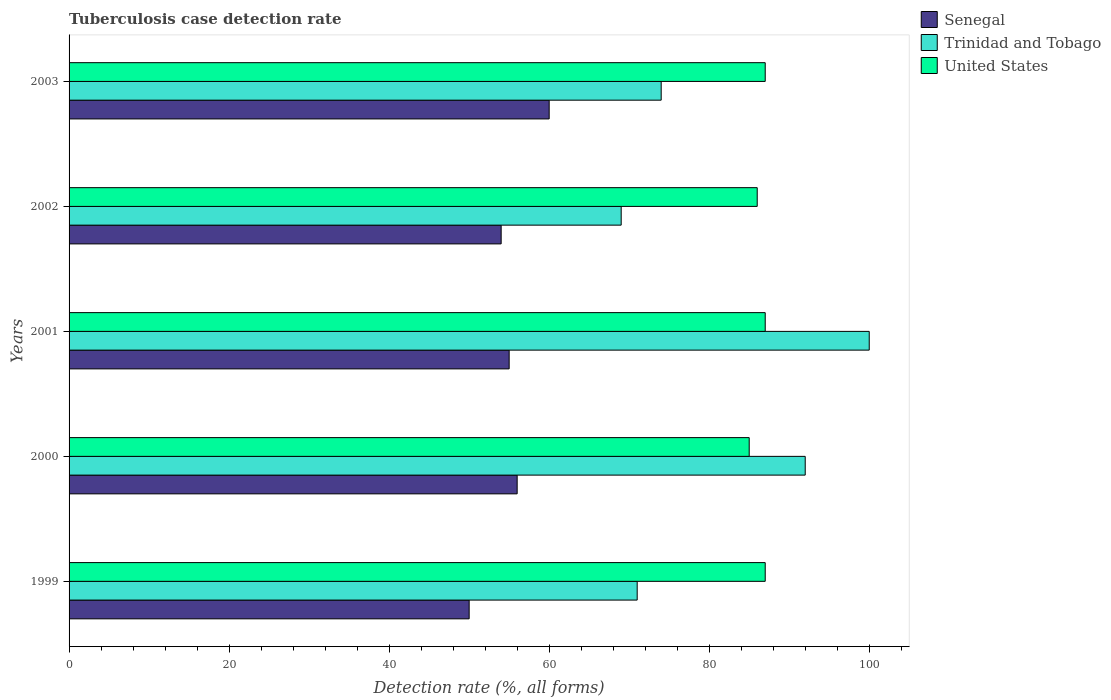Are the number of bars per tick equal to the number of legend labels?
Your response must be concise. Yes. How many bars are there on the 1st tick from the top?
Your answer should be very brief. 3. How many bars are there on the 2nd tick from the bottom?
Ensure brevity in your answer.  3. What is the label of the 4th group of bars from the top?
Make the answer very short. 2000. In how many cases, is the number of bars for a given year not equal to the number of legend labels?
Your response must be concise. 0. What is the tuberculosis case detection rate in in United States in 2001?
Provide a short and direct response. 87. Across all years, what is the maximum tuberculosis case detection rate in in Senegal?
Your answer should be very brief. 60. Across all years, what is the minimum tuberculosis case detection rate in in Senegal?
Ensure brevity in your answer.  50. What is the total tuberculosis case detection rate in in Senegal in the graph?
Your response must be concise. 275. What is the difference between the tuberculosis case detection rate in in Trinidad and Tobago in 2000 and that in 2003?
Keep it short and to the point. 18. What is the difference between the tuberculosis case detection rate in in Trinidad and Tobago in 2000 and the tuberculosis case detection rate in in United States in 1999?
Offer a terse response. 5. What is the average tuberculosis case detection rate in in United States per year?
Provide a succinct answer. 86.4. In the year 2003, what is the difference between the tuberculosis case detection rate in in Senegal and tuberculosis case detection rate in in Trinidad and Tobago?
Ensure brevity in your answer.  -14. What is the ratio of the tuberculosis case detection rate in in Trinidad and Tobago in 2000 to that in 2002?
Ensure brevity in your answer.  1.33. Is the tuberculosis case detection rate in in Senegal in 1999 less than that in 2002?
Your answer should be very brief. Yes. Is the difference between the tuberculosis case detection rate in in Senegal in 2001 and 2003 greater than the difference between the tuberculosis case detection rate in in Trinidad and Tobago in 2001 and 2003?
Offer a terse response. No. What is the difference between the highest and the second highest tuberculosis case detection rate in in Trinidad and Tobago?
Offer a very short reply. 8. What is the difference between the highest and the lowest tuberculosis case detection rate in in Trinidad and Tobago?
Keep it short and to the point. 31. In how many years, is the tuberculosis case detection rate in in Trinidad and Tobago greater than the average tuberculosis case detection rate in in Trinidad and Tobago taken over all years?
Ensure brevity in your answer.  2. What does the 3rd bar from the top in 2000 represents?
Make the answer very short. Senegal. What does the 2nd bar from the bottom in 2001 represents?
Ensure brevity in your answer.  Trinidad and Tobago. How many bars are there?
Keep it short and to the point. 15. Where does the legend appear in the graph?
Offer a very short reply. Top right. How are the legend labels stacked?
Offer a terse response. Vertical. What is the title of the graph?
Provide a succinct answer. Tuberculosis case detection rate. Does "Mongolia" appear as one of the legend labels in the graph?
Give a very brief answer. No. What is the label or title of the X-axis?
Offer a very short reply. Detection rate (%, all forms). What is the Detection rate (%, all forms) of Senegal in 1999?
Provide a succinct answer. 50. What is the Detection rate (%, all forms) of Trinidad and Tobago in 2000?
Offer a very short reply. 92. What is the Detection rate (%, all forms) in Senegal in 2001?
Make the answer very short. 55. What is the Detection rate (%, all forms) of United States in 2001?
Offer a very short reply. 87. What is the Detection rate (%, all forms) in Senegal in 2002?
Ensure brevity in your answer.  54. What is the Detection rate (%, all forms) in Trinidad and Tobago in 2002?
Offer a very short reply. 69. What is the Detection rate (%, all forms) of Senegal in 2003?
Your answer should be very brief. 60. What is the Detection rate (%, all forms) in Trinidad and Tobago in 2003?
Your answer should be very brief. 74. What is the Detection rate (%, all forms) in United States in 2003?
Your response must be concise. 87. What is the total Detection rate (%, all forms) of Senegal in the graph?
Make the answer very short. 275. What is the total Detection rate (%, all forms) in Trinidad and Tobago in the graph?
Make the answer very short. 406. What is the total Detection rate (%, all forms) of United States in the graph?
Provide a succinct answer. 432. What is the difference between the Detection rate (%, all forms) of Senegal in 1999 and that in 2000?
Your answer should be compact. -6. What is the difference between the Detection rate (%, all forms) in United States in 1999 and that in 2000?
Your response must be concise. 2. What is the difference between the Detection rate (%, all forms) in United States in 1999 and that in 2002?
Make the answer very short. 1. What is the difference between the Detection rate (%, all forms) of Senegal in 1999 and that in 2003?
Provide a short and direct response. -10. What is the difference between the Detection rate (%, all forms) of Trinidad and Tobago in 1999 and that in 2003?
Your response must be concise. -3. What is the difference between the Detection rate (%, all forms) in United States in 1999 and that in 2003?
Your answer should be compact. 0. What is the difference between the Detection rate (%, all forms) in Senegal in 2000 and that in 2001?
Offer a terse response. 1. What is the difference between the Detection rate (%, all forms) of Trinidad and Tobago in 2000 and that in 2001?
Keep it short and to the point. -8. What is the difference between the Detection rate (%, all forms) of United States in 2000 and that in 2001?
Your response must be concise. -2. What is the difference between the Detection rate (%, all forms) in United States in 2000 and that in 2002?
Provide a short and direct response. -1. What is the difference between the Detection rate (%, all forms) in United States in 2000 and that in 2003?
Make the answer very short. -2. What is the difference between the Detection rate (%, all forms) of Trinidad and Tobago in 2001 and that in 2002?
Make the answer very short. 31. What is the difference between the Detection rate (%, all forms) in United States in 2001 and that in 2003?
Keep it short and to the point. 0. What is the difference between the Detection rate (%, all forms) in United States in 2002 and that in 2003?
Your answer should be compact. -1. What is the difference between the Detection rate (%, all forms) in Senegal in 1999 and the Detection rate (%, all forms) in Trinidad and Tobago in 2000?
Ensure brevity in your answer.  -42. What is the difference between the Detection rate (%, all forms) in Senegal in 1999 and the Detection rate (%, all forms) in United States in 2000?
Offer a terse response. -35. What is the difference between the Detection rate (%, all forms) of Trinidad and Tobago in 1999 and the Detection rate (%, all forms) of United States in 2000?
Make the answer very short. -14. What is the difference between the Detection rate (%, all forms) in Senegal in 1999 and the Detection rate (%, all forms) in United States in 2001?
Give a very brief answer. -37. What is the difference between the Detection rate (%, all forms) of Senegal in 1999 and the Detection rate (%, all forms) of United States in 2002?
Make the answer very short. -36. What is the difference between the Detection rate (%, all forms) in Trinidad and Tobago in 1999 and the Detection rate (%, all forms) in United States in 2002?
Make the answer very short. -15. What is the difference between the Detection rate (%, all forms) of Senegal in 1999 and the Detection rate (%, all forms) of United States in 2003?
Your answer should be very brief. -37. What is the difference between the Detection rate (%, all forms) of Senegal in 2000 and the Detection rate (%, all forms) of Trinidad and Tobago in 2001?
Your answer should be very brief. -44. What is the difference between the Detection rate (%, all forms) in Senegal in 2000 and the Detection rate (%, all forms) in United States in 2001?
Provide a succinct answer. -31. What is the difference between the Detection rate (%, all forms) in Trinidad and Tobago in 2000 and the Detection rate (%, all forms) in United States in 2001?
Provide a succinct answer. 5. What is the difference between the Detection rate (%, all forms) in Senegal in 2000 and the Detection rate (%, all forms) in United States in 2002?
Your answer should be compact. -30. What is the difference between the Detection rate (%, all forms) of Trinidad and Tobago in 2000 and the Detection rate (%, all forms) of United States in 2002?
Make the answer very short. 6. What is the difference between the Detection rate (%, all forms) in Senegal in 2000 and the Detection rate (%, all forms) in United States in 2003?
Your answer should be very brief. -31. What is the difference between the Detection rate (%, all forms) in Trinidad and Tobago in 2000 and the Detection rate (%, all forms) in United States in 2003?
Your response must be concise. 5. What is the difference between the Detection rate (%, all forms) in Senegal in 2001 and the Detection rate (%, all forms) in United States in 2002?
Make the answer very short. -31. What is the difference between the Detection rate (%, all forms) in Senegal in 2001 and the Detection rate (%, all forms) in Trinidad and Tobago in 2003?
Give a very brief answer. -19. What is the difference between the Detection rate (%, all forms) in Senegal in 2001 and the Detection rate (%, all forms) in United States in 2003?
Make the answer very short. -32. What is the difference between the Detection rate (%, all forms) in Trinidad and Tobago in 2001 and the Detection rate (%, all forms) in United States in 2003?
Your response must be concise. 13. What is the difference between the Detection rate (%, all forms) of Senegal in 2002 and the Detection rate (%, all forms) of United States in 2003?
Your answer should be very brief. -33. What is the difference between the Detection rate (%, all forms) in Trinidad and Tobago in 2002 and the Detection rate (%, all forms) in United States in 2003?
Your answer should be very brief. -18. What is the average Detection rate (%, all forms) of Senegal per year?
Provide a succinct answer. 55. What is the average Detection rate (%, all forms) in Trinidad and Tobago per year?
Provide a short and direct response. 81.2. What is the average Detection rate (%, all forms) of United States per year?
Ensure brevity in your answer.  86.4. In the year 1999, what is the difference between the Detection rate (%, all forms) in Senegal and Detection rate (%, all forms) in United States?
Your response must be concise. -37. In the year 2000, what is the difference between the Detection rate (%, all forms) of Senegal and Detection rate (%, all forms) of Trinidad and Tobago?
Keep it short and to the point. -36. In the year 2000, what is the difference between the Detection rate (%, all forms) of Senegal and Detection rate (%, all forms) of United States?
Your answer should be very brief. -29. In the year 2001, what is the difference between the Detection rate (%, all forms) of Senegal and Detection rate (%, all forms) of Trinidad and Tobago?
Provide a short and direct response. -45. In the year 2001, what is the difference between the Detection rate (%, all forms) of Senegal and Detection rate (%, all forms) of United States?
Make the answer very short. -32. In the year 2002, what is the difference between the Detection rate (%, all forms) in Senegal and Detection rate (%, all forms) in Trinidad and Tobago?
Offer a very short reply. -15. In the year 2002, what is the difference between the Detection rate (%, all forms) in Senegal and Detection rate (%, all forms) in United States?
Your answer should be compact. -32. In the year 2002, what is the difference between the Detection rate (%, all forms) of Trinidad and Tobago and Detection rate (%, all forms) of United States?
Ensure brevity in your answer.  -17. In the year 2003, what is the difference between the Detection rate (%, all forms) of Senegal and Detection rate (%, all forms) of United States?
Ensure brevity in your answer.  -27. What is the ratio of the Detection rate (%, all forms) of Senegal in 1999 to that in 2000?
Ensure brevity in your answer.  0.89. What is the ratio of the Detection rate (%, all forms) in Trinidad and Tobago in 1999 to that in 2000?
Keep it short and to the point. 0.77. What is the ratio of the Detection rate (%, all forms) in United States in 1999 to that in 2000?
Ensure brevity in your answer.  1.02. What is the ratio of the Detection rate (%, all forms) of Trinidad and Tobago in 1999 to that in 2001?
Ensure brevity in your answer.  0.71. What is the ratio of the Detection rate (%, all forms) of Senegal in 1999 to that in 2002?
Your answer should be very brief. 0.93. What is the ratio of the Detection rate (%, all forms) of United States in 1999 to that in 2002?
Your answer should be compact. 1.01. What is the ratio of the Detection rate (%, all forms) in Senegal in 1999 to that in 2003?
Offer a very short reply. 0.83. What is the ratio of the Detection rate (%, all forms) of Trinidad and Tobago in 1999 to that in 2003?
Keep it short and to the point. 0.96. What is the ratio of the Detection rate (%, all forms) in Senegal in 2000 to that in 2001?
Your response must be concise. 1.02. What is the ratio of the Detection rate (%, all forms) of Trinidad and Tobago in 2000 to that in 2001?
Provide a succinct answer. 0.92. What is the ratio of the Detection rate (%, all forms) of Trinidad and Tobago in 2000 to that in 2002?
Provide a short and direct response. 1.33. What is the ratio of the Detection rate (%, all forms) of United States in 2000 to that in 2002?
Provide a short and direct response. 0.99. What is the ratio of the Detection rate (%, all forms) of Trinidad and Tobago in 2000 to that in 2003?
Provide a short and direct response. 1.24. What is the ratio of the Detection rate (%, all forms) in Senegal in 2001 to that in 2002?
Your answer should be compact. 1.02. What is the ratio of the Detection rate (%, all forms) of Trinidad and Tobago in 2001 to that in 2002?
Offer a very short reply. 1.45. What is the ratio of the Detection rate (%, all forms) of United States in 2001 to that in 2002?
Ensure brevity in your answer.  1.01. What is the ratio of the Detection rate (%, all forms) of Senegal in 2001 to that in 2003?
Provide a short and direct response. 0.92. What is the ratio of the Detection rate (%, all forms) in Trinidad and Tobago in 2001 to that in 2003?
Offer a very short reply. 1.35. What is the ratio of the Detection rate (%, all forms) in United States in 2001 to that in 2003?
Ensure brevity in your answer.  1. What is the ratio of the Detection rate (%, all forms) of Senegal in 2002 to that in 2003?
Your answer should be compact. 0.9. What is the ratio of the Detection rate (%, all forms) in Trinidad and Tobago in 2002 to that in 2003?
Give a very brief answer. 0.93. What is the ratio of the Detection rate (%, all forms) in United States in 2002 to that in 2003?
Provide a short and direct response. 0.99. What is the difference between the highest and the second highest Detection rate (%, all forms) of United States?
Give a very brief answer. 0. What is the difference between the highest and the lowest Detection rate (%, all forms) of Senegal?
Provide a succinct answer. 10. What is the difference between the highest and the lowest Detection rate (%, all forms) in United States?
Give a very brief answer. 2. 